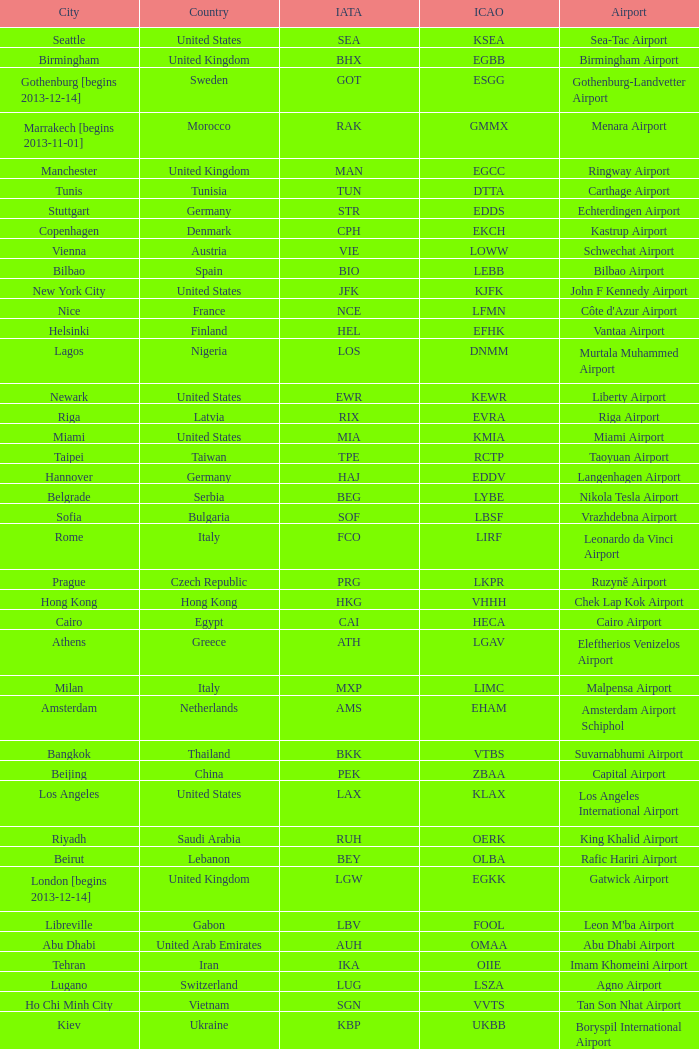What is the ICAO of Douala city? FKKD. 